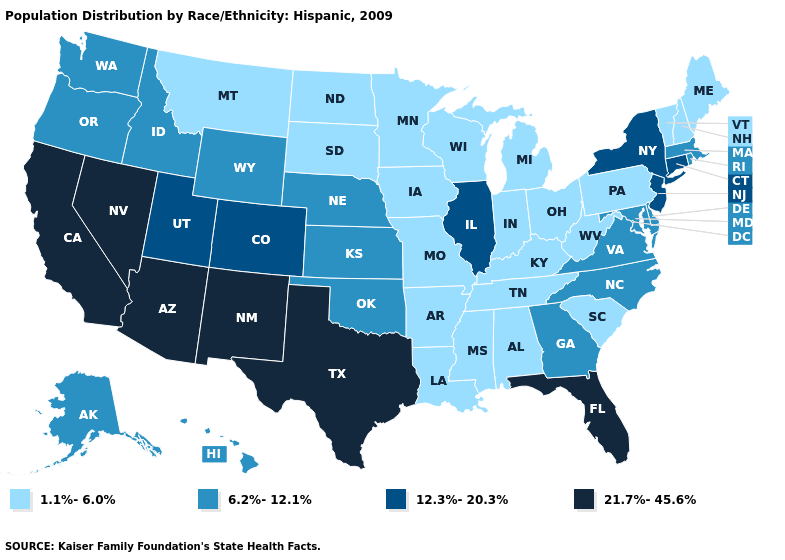Name the states that have a value in the range 1.1%-6.0%?
Keep it brief. Alabama, Arkansas, Indiana, Iowa, Kentucky, Louisiana, Maine, Michigan, Minnesota, Mississippi, Missouri, Montana, New Hampshire, North Dakota, Ohio, Pennsylvania, South Carolina, South Dakota, Tennessee, Vermont, West Virginia, Wisconsin. Among the states that border Arizona , which have the lowest value?
Be succinct. Colorado, Utah. Does Illinois have the highest value in the MidWest?
Concise answer only. Yes. What is the highest value in states that border Kansas?
Quick response, please. 12.3%-20.3%. Does Rhode Island have a lower value than New York?
Write a very short answer. Yes. Which states hav the highest value in the Northeast?
Short answer required. Connecticut, New Jersey, New York. What is the value of California?
Answer briefly. 21.7%-45.6%. What is the highest value in the South ?
Answer briefly. 21.7%-45.6%. Does the first symbol in the legend represent the smallest category?
Short answer required. Yes. What is the value of Arkansas?
Answer briefly. 1.1%-6.0%. Among the states that border South Carolina , which have the highest value?
Quick response, please. Georgia, North Carolina. Does Utah have the same value as Alabama?
Short answer required. No. What is the value of Delaware?
Keep it brief. 6.2%-12.1%. Name the states that have a value in the range 12.3%-20.3%?
Be succinct. Colorado, Connecticut, Illinois, New Jersey, New York, Utah. Name the states that have a value in the range 21.7%-45.6%?
Short answer required. Arizona, California, Florida, Nevada, New Mexico, Texas. 